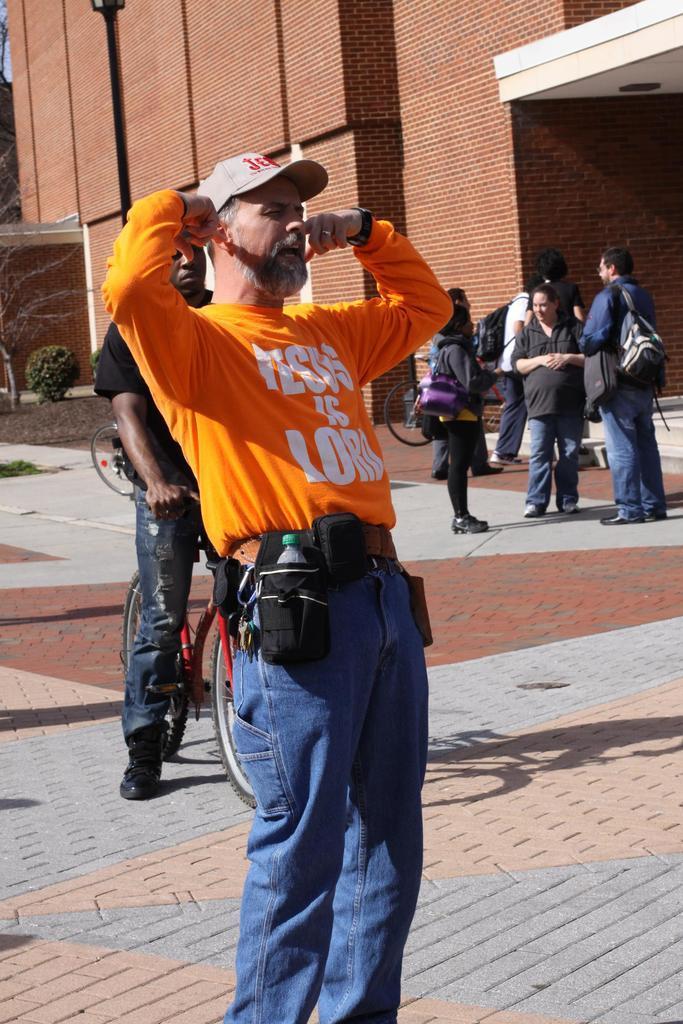In one or two sentences, can you explain what this image depicts? In the picture we can see a path with tiles on it we can see a man standing, he is in orange T-shirt and a white cap and closing his ears with his hands and behind him we can see one man sitting on the bicycle and behind him we can see three people are standing and talking to each other and in the background we can see a building wall and near it we can see some plant. 